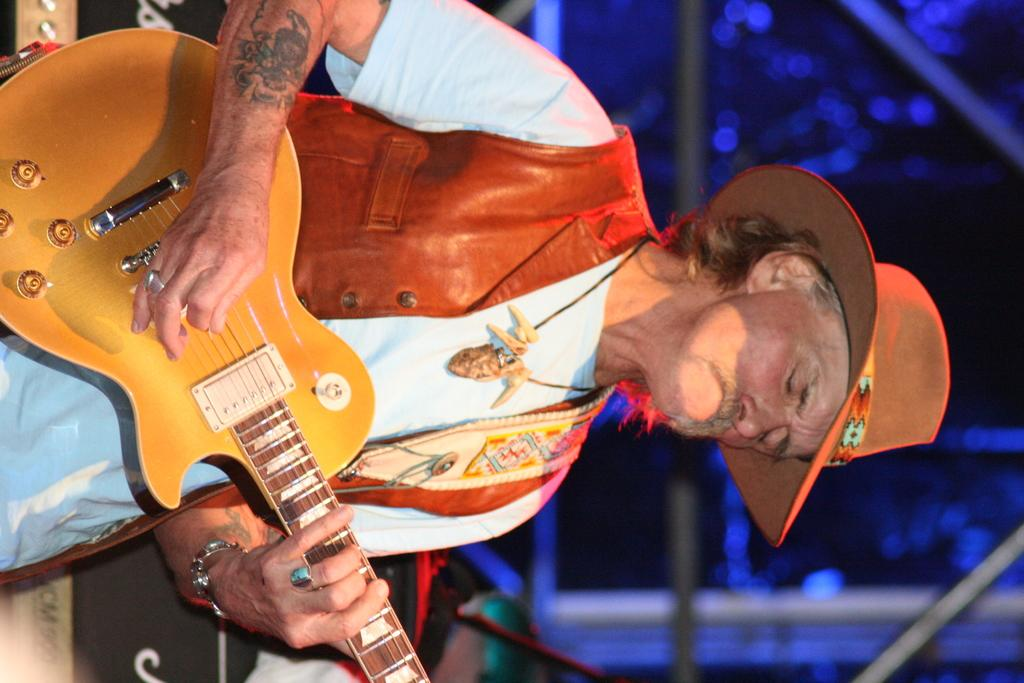What type of clothing is the man wearing on his upper body in the image? The man is wearing a brown jacket. What type of headwear is the man wearing in the image? The man is wearing a hat. What is the man doing in the image? The man is playing a guitar. Reasoning: Let' Let's think step by step in order to produce the conversation. We start by identifying the main subject in the image, which is the man. Then, we describe the clothing and accessories he is wearing, including his brown jacket and hat. Finally, we focus on the man's activity in the image, which is playing a guitar. Each question is designed to elicit a specific detail about the image that is known from the provided facts. Absurd Question/Answer: What type of watch is the man wearing in the image? There is no watch visible in the image. What type of juice is the man drinking in the image? There is no juice or any indication of the man consuming a beverage in the image. What type of watch is the man wearing in the image? There is no watch visible in the image. What type of juice is the man drinking in the image? There is no juice or any indication of the man consuming a beverage in the image. 